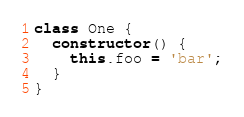Convert code to text. <code><loc_0><loc_0><loc_500><loc_500><_JavaScript_>class One {
  constructor() {
    this.foo = 'bar';
  }
}
</code> 